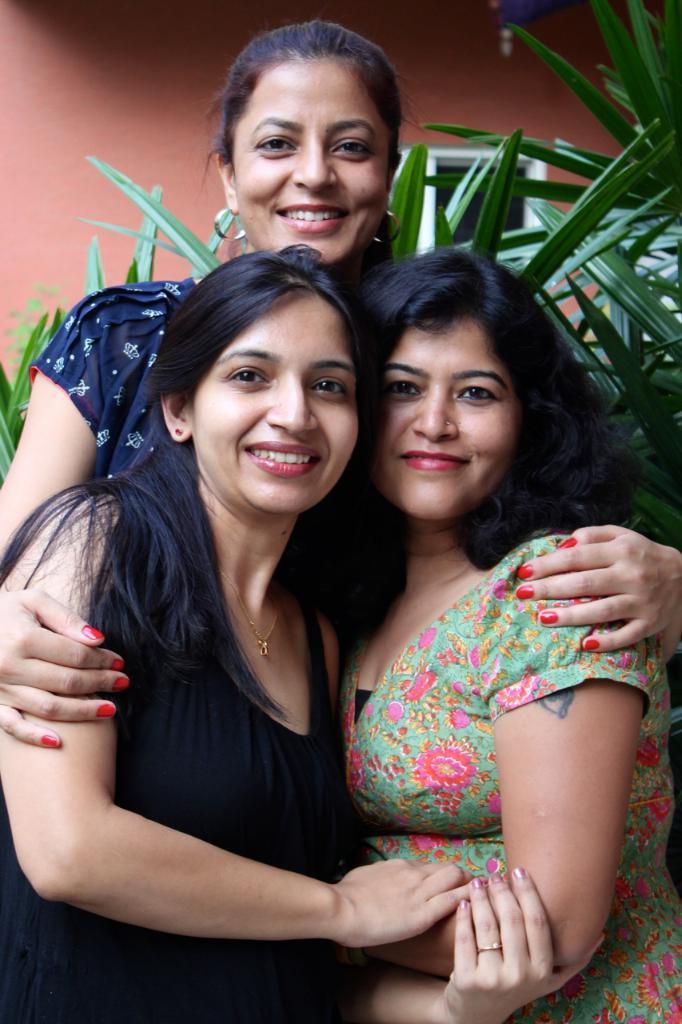How would you summarize this image in a sentence or two? In the center of the image, we can see three ladies smiling and in the background, there are plants and we can see a window on the wall. 